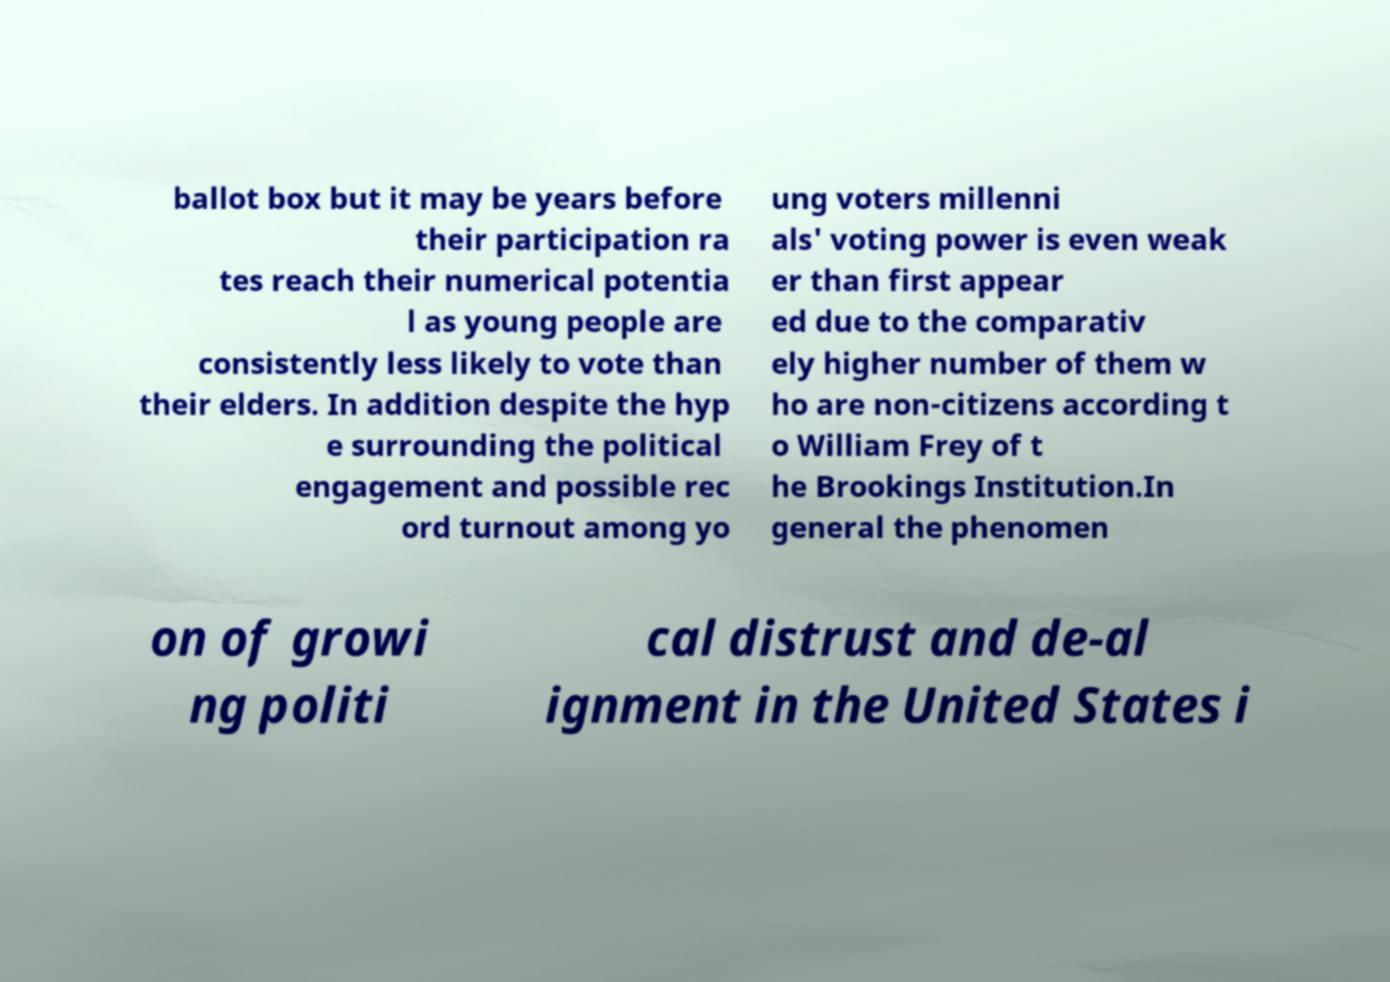Could you extract and type out the text from this image? ballot box but it may be years before their participation ra tes reach their numerical potentia l as young people are consistently less likely to vote than their elders. In addition despite the hyp e surrounding the political engagement and possible rec ord turnout among yo ung voters millenni als' voting power is even weak er than first appear ed due to the comparativ ely higher number of them w ho are non-citizens according t o William Frey of t he Brookings Institution.In general the phenomen on of growi ng politi cal distrust and de-al ignment in the United States i 